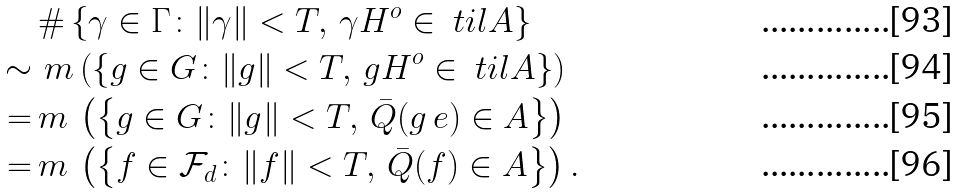<formula> <loc_0><loc_0><loc_500><loc_500>& \# \left \{ \gamma \in \Gamma \colon \| \gamma \| < T , \, \gamma H ^ { o } \in \ t i l A \right \} \\ \sim \, & \, m \left ( \left \{ g \in G \colon \| g \| < T , \, g H ^ { o } \in \ t i l A \right \} \right ) \\ = \, & m \, \left ( \left \{ g \in G \colon \| g \| < T , \, \bar { Q } ( g \, { e } ) \in A \right \} \right ) \\ = \, & m \, \left ( \left \{ f \in \mathcal { F } _ { d } \colon \| f \| < T , \, \bar { Q } ( f ) \in A \right \} \right ) .</formula> 